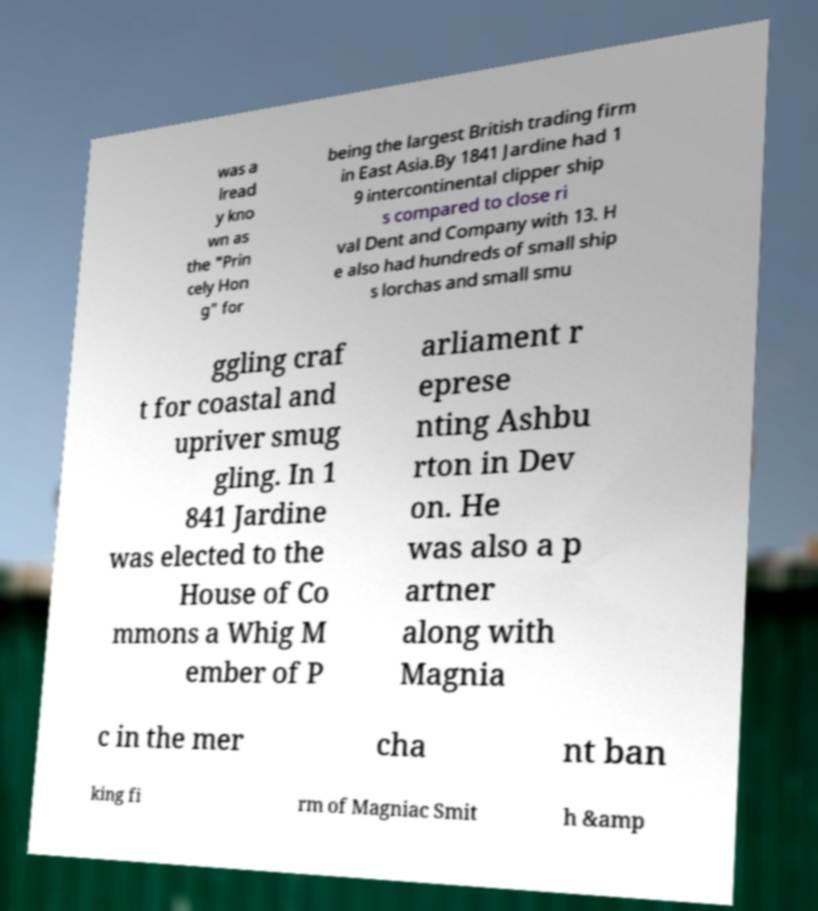Can you accurately transcribe the text from the provided image for me? was a lread y kno wn as the "Prin cely Hon g" for being the largest British trading firm in East Asia.By 1841 Jardine had 1 9 intercontinental clipper ship s compared to close ri val Dent and Company with 13. H e also had hundreds of small ship s lorchas and small smu ggling craf t for coastal and upriver smug gling. In 1 841 Jardine was elected to the House of Co mmons a Whig M ember of P arliament r eprese nting Ashbu rton in Dev on. He was also a p artner along with Magnia c in the mer cha nt ban king fi rm of Magniac Smit h &amp 